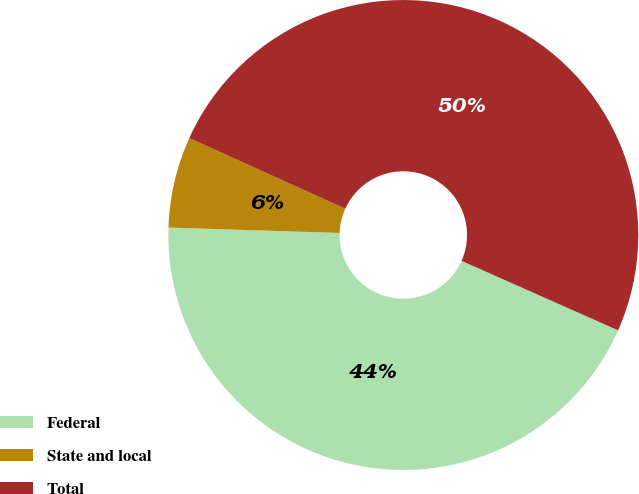Convert chart. <chart><loc_0><loc_0><loc_500><loc_500><pie_chart><fcel>Federal<fcel>State and local<fcel>Total<nl><fcel>43.85%<fcel>6.26%<fcel>49.88%<nl></chart> 